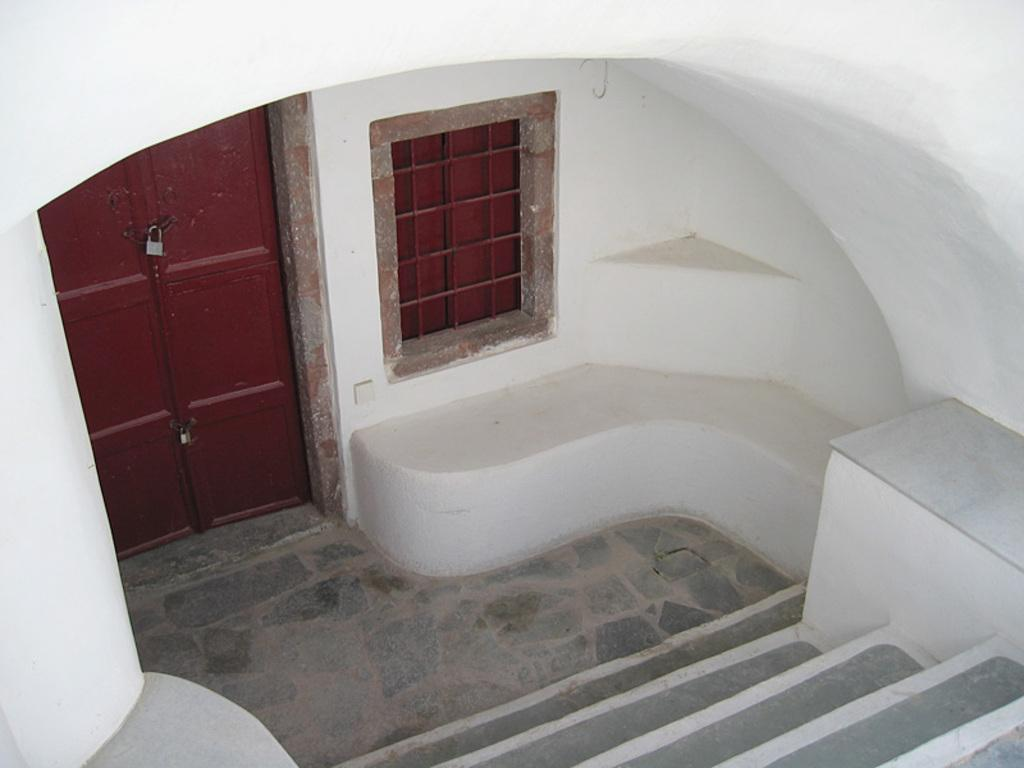What architectural feature is located at the bottom of the image? There are stairs at the bottom of the image. What can be found in the center of the image? There is a door and a window in the center of the image. What is at the top of the image? There is an arch at the top of the image. What type of whip can be seen in the image? There is no whip present in the image. What is the visibility like in the image due to the fog? There is no fog present in the image, so visibility is not affected. 